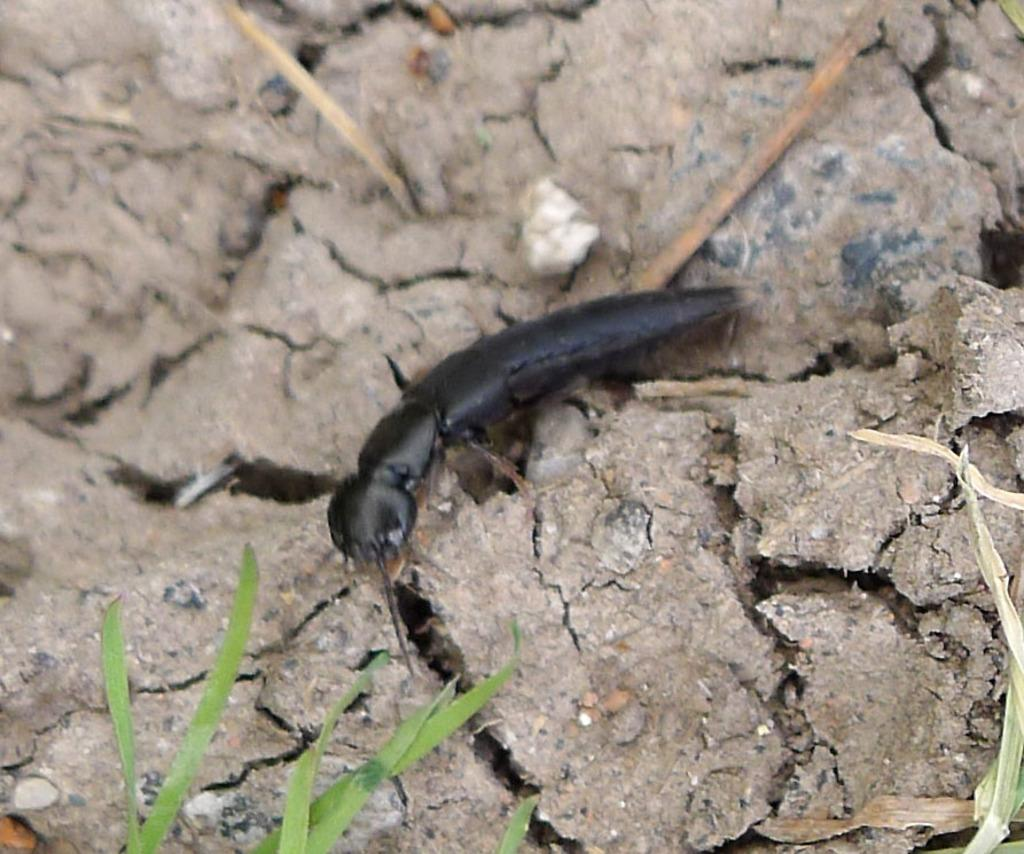What type of creature can be seen in the image? There is an insect in the image. Where is the insect located? The insect is on the ground. What type of vegetation is present in the image? There is grass in the image. What type of haircut does the insect have in the image? There is no indication of a haircut for the insect in the image, as insects do not have hair. 